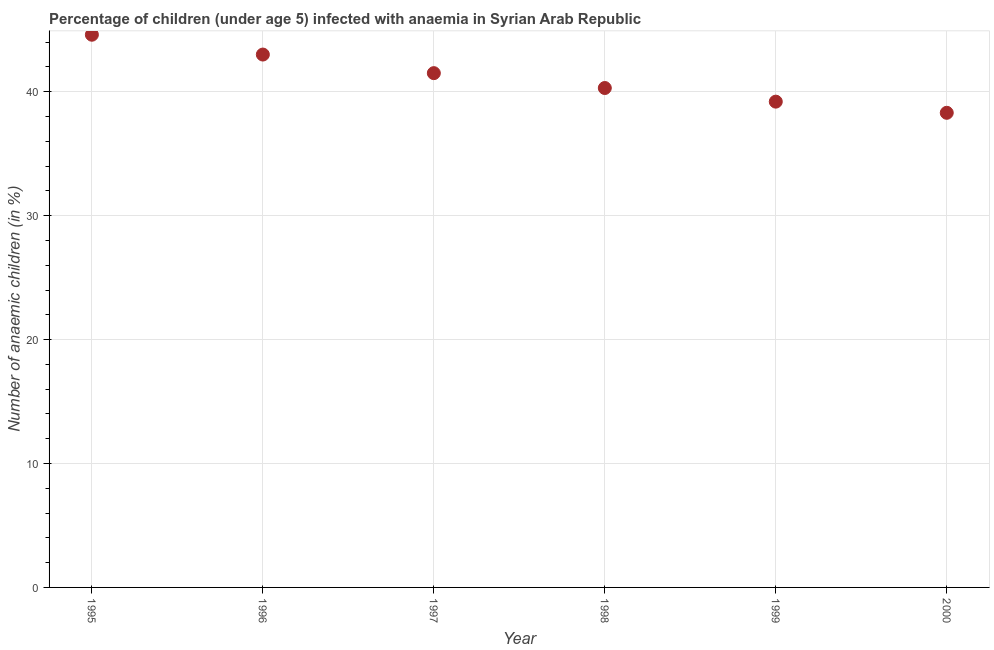Across all years, what is the maximum number of anaemic children?
Offer a very short reply. 44.6. Across all years, what is the minimum number of anaemic children?
Give a very brief answer. 38.3. What is the sum of the number of anaemic children?
Give a very brief answer. 246.9. What is the difference between the number of anaemic children in 1997 and 2000?
Your answer should be very brief. 3.2. What is the average number of anaemic children per year?
Provide a short and direct response. 41.15. What is the median number of anaemic children?
Offer a terse response. 40.9. What is the ratio of the number of anaemic children in 1996 to that in 1997?
Provide a short and direct response. 1.04. What is the difference between the highest and the second highest number of anaemic children?
Your answer should be very brief. 1.6. What is the difference between the highest and the lowest number of anaemic children?
Ensure brevity in your answer.  6.3. In how many years, is the number of anaemic children greater than the average number of anaemic children taken over all years?
Offer a terse response. 3. Does the number of anaemic children monotonically increase over the years?
Keep it short and to the point. No. How many dotlines are there?
Your answer should be compact. 1. What is the difference between two consecutive major ticks on the Y-axis?
Your answer should be very brief. 10. Does the graph contain any zero values?
Offer a terse response. No. Does the graph contain grids?
Your answer should be very brief. Yes. What is the title of the graph?
Your answer should be very brief. Percentage of children (under age 5) infected with anaemia in Syrian Arab Republic. What is the label or title of the Y-axis?
Your answer should be compact. Number of anaemic children (in %). What is the Number of anaemic children (in %) in 1995?
Provide a succinct answer. 44.6. What is the Number of anaemic children (in %) in 1997?
Ensure brevity in your answer.  41.5. What is the Number of anaemic children (in %) in 1998?
Give a very brief answer. 40.3. What is the Number of anaemic children (in %) in 1999?
Provide a short and direct response. 39.2. What is the Number of anaemic children (in %) in 2000?
Make the answer very short. 38.3. What is the difference between the Number of anaemic children (in %) in 1995 and 1997?
Your response must be concise. 3.1. What is the difference between the Number of anaemic children (in %) in 1995 and 1999?
Provide a succinct answer. 5.4. What is the difference between the Number of anaemic children (in %) in 1996 and 1997?
Give a very brief answer. 1.5. What is the difference between the Number of anaemic children (in %) in 1996 and 1998?
Provide a succinct answer. 2.7. What is the difference between the Number of anaemic children (in %) in 1997 and 1998?
Provide a succinct answer. 1.2. What is the difference between the Number of anaemic children (in %) in 1997 and 1999?
Keep it short and to the point. 2.3. What is the difference between the Number of anaemic children (in %) in 1997 and 2000?
Ensure brevity in your answer.  3.2. What is the ratio of the Number of anaemic children (in %) in 1995 to that in 1997?
Your answer should be very brief. 1.07. What is the ratio of the Number of anaemic children (in %) in 1995 to that in 1998?
Provide a succinct answer. 1.11. What is the ratio of the Number of anaemic children (in %) in 1995 to that in 1999?
Ensure brevity in your answer.  1.14. What is the ratio of the Number of anaemic children (in %) in 1995 to that in 2000?
Keep it short and to the point. 1.16. What is the ratio of the Number of anaemic children (in %) in 1996 to that in 1997?
Your answer should be compact. 1.04. What is the ratio of the Number of anaemic children (in %) in 1996 to that in 1998?
Offer a terse response. 1.07. What is the ratio of the Number of anaemic children (in %) in 1996 to that in 1999?
Your response must be concise. 1.1. What is the ratio of the Number of anaemic children (in %) in 1996 to that in 2000?
Provide a succinct answer. 1.12. What is the ratio of the Number of anaemic children (in %) in 1997 to that in 1998?
Ensure brevity in your answer.  1.03. What is the ratio of the Number of anaemic children (in %) in 1997 to that in 1999?
Your answer should be compact. 1.06. What is the ratio of the Number of anaemic children (in %) in 1997 to that in 2000?
Your answer should be compact. 1.08. What is the ratio of the Number of anaemic children (in %) in 1998 to that in 1999?
Your response must be concise. 1.03. What is the ratio of the Number of anaemic children (in %) in 1998 to that in 2000?
Your response must be concise. 1.05. What is the ratio of the Number of anaemic children (in %) in 1999 to that in 2000?
Provide a succinct answer. 1.02. 